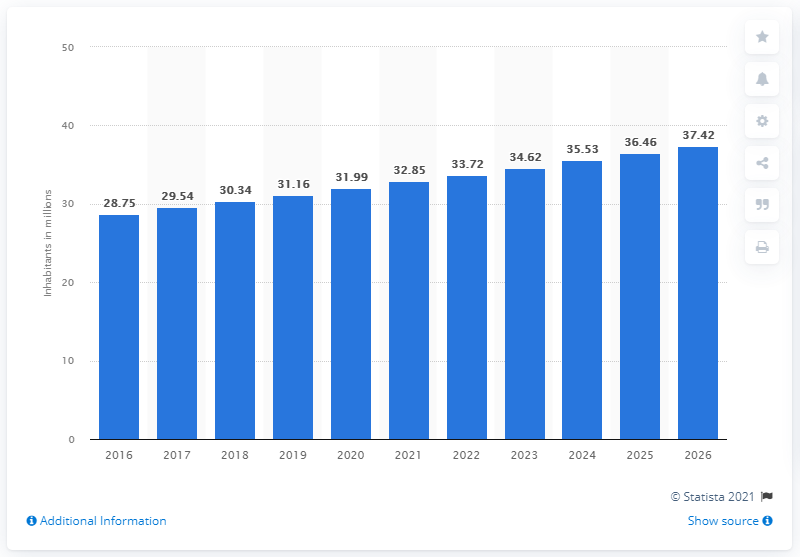Specify some key components in this picture. In 2015, the population of Mozambique was 31.99 million. Projections of the population of Mozambique are expected to continue until 2026. 